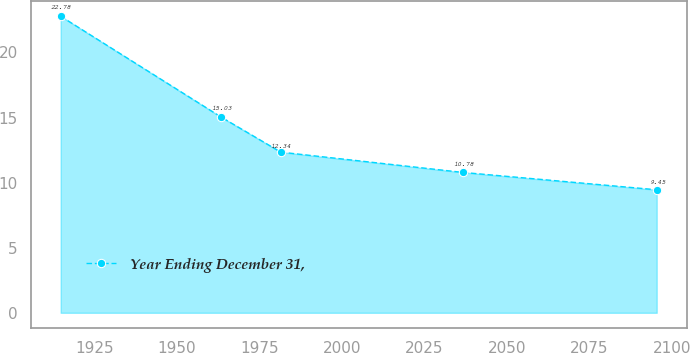Convert chart to OTSL. <chart><loc_0><loc_0><loc_500><loc_500><line_chart><ecel><fcel>Year Ending December 31,<nl><fcel>1914.77<fcel>22.78<nl><fcel>1963.43<fcel>15.03<nl><fcel>1981.5<fcel>12.34<nl><fcel>2036.79<fcel>10.78<nl><fcel>2095.44<fcel>9.45<nl></chart> 